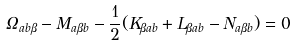<formula> <loc_0><loc_0><loc_500><loc_500>\Omega _ { a b { \beta } } - M _ { a { \beta } b } - \frac { 1 } { 2 } ( K _ { { \beta } a b } + L _ { { \beta } a b } - N _ { a { \beta } b } ) = 0</formula> 